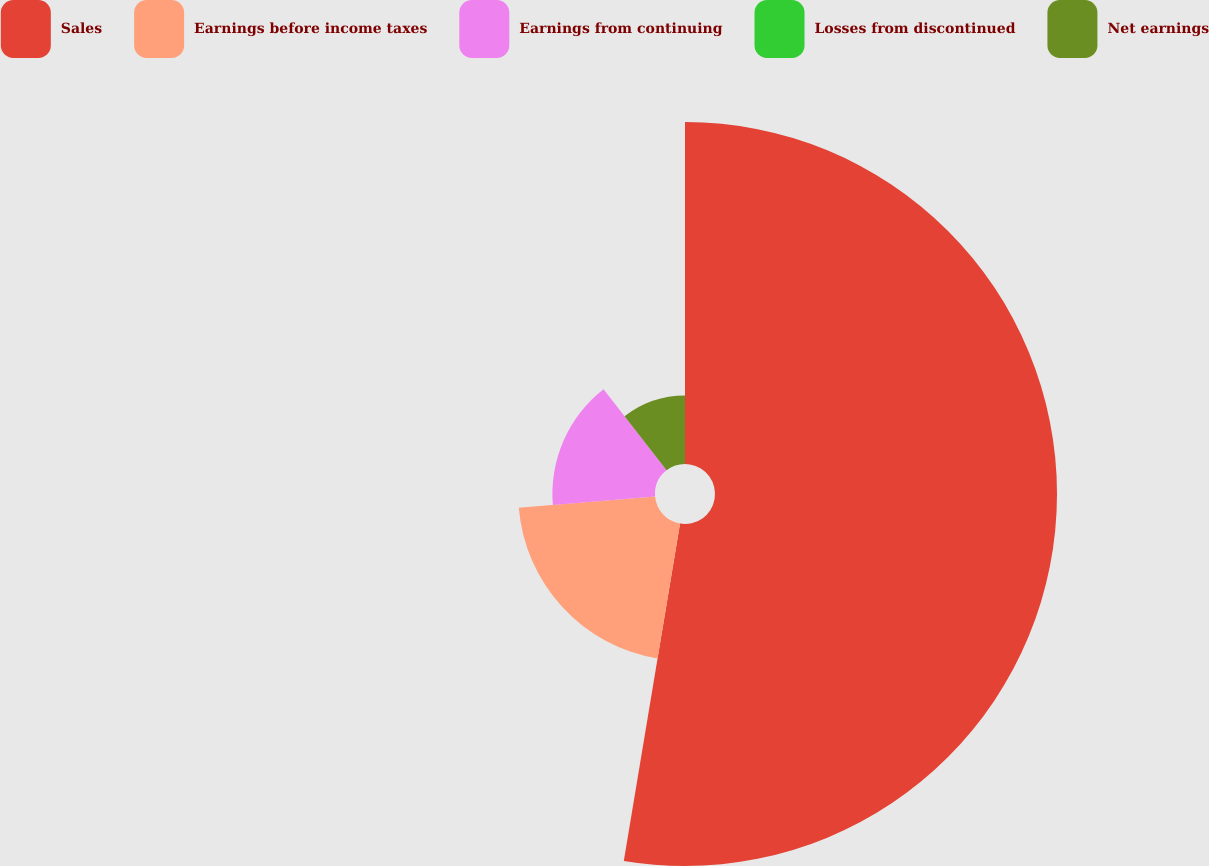Convert chart to OTSL. <chart><loc_0><loc_0><loc_500><loc_500><pie_chart><fcel>Sales<fcel>Earnings before income taxes<fcel>Earnings from continuing<fcel>Losses from discontinued<fcel>Net earnings<nl><fcel>52.63%<fcel>21.05%<fcel>15.79%<fcel>0.0%<fcel>10.53%<nl></chart> 